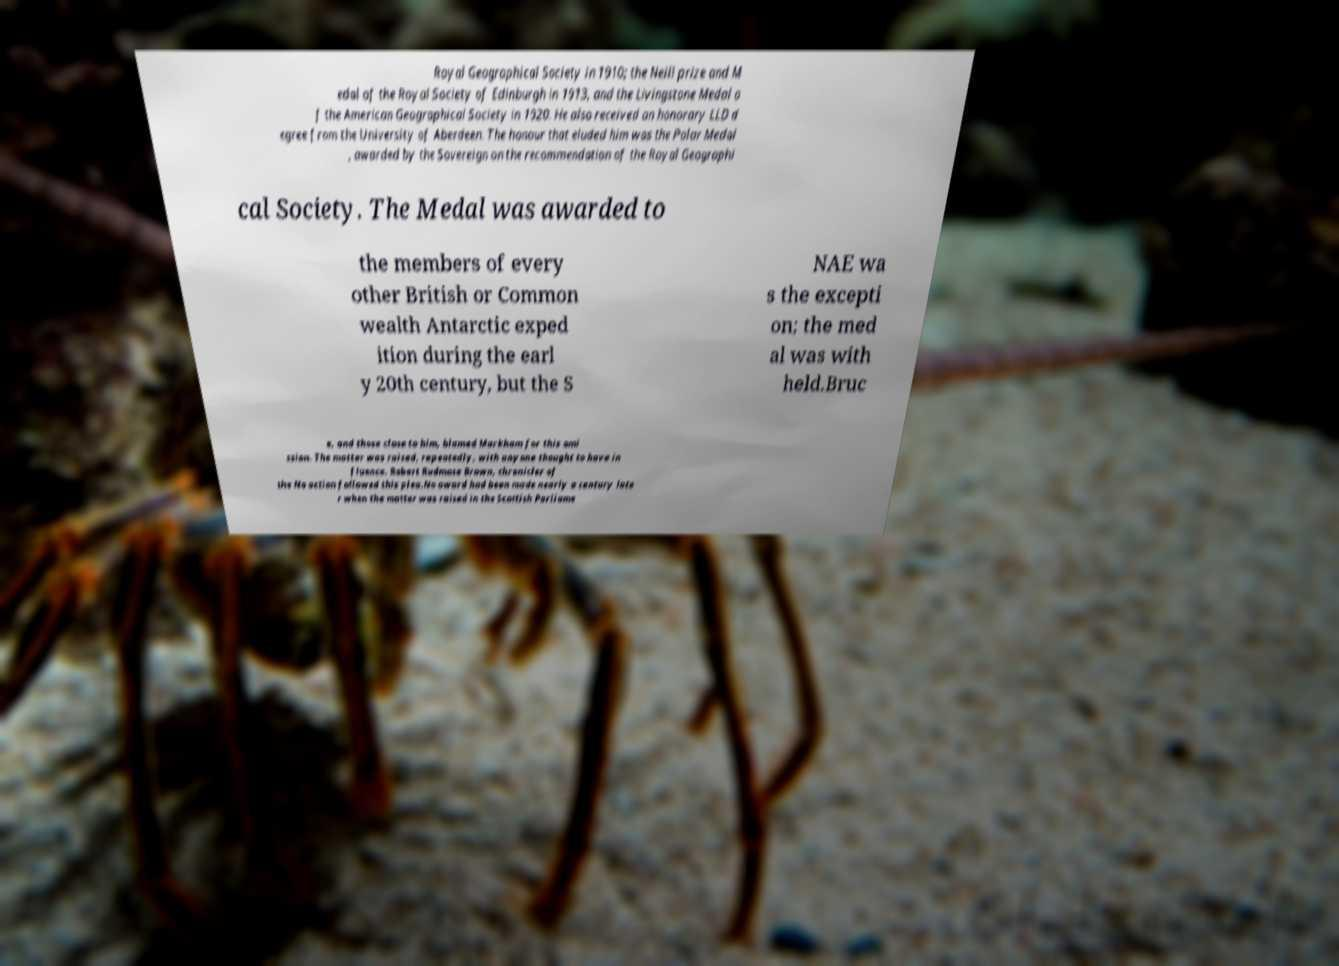Please identify and transcribe the text found in this image. Royal Geographical Society in 1910; the Neill prize and M edal of the Royal Society of Edinburgh in 1913, and the Livingstone Medal o f the American Geographical Society in 1920. He also received an honorary LLD d egree from the University of Aberdeen. The honour that eluded him was the Polar Medal , awarded by the Sovereign on the recommendation of the Royal Geographi cal Society. The Medal was awarded to the members of every other British or Common wealth Antarctic exped ition during the earl y 20th century, but the S NAE wa s the excepti on; the med al was with held.Bruc e, and those close to him, blamed Markham for this omi ssion. The matter was raised, repeatedly, with anyone thought to have in fluence. Robert Rudmose Brown, chronicler of the No action followed this plea.No award had been made nearly a century late r when the matter was raised in the Scottish Parliame 